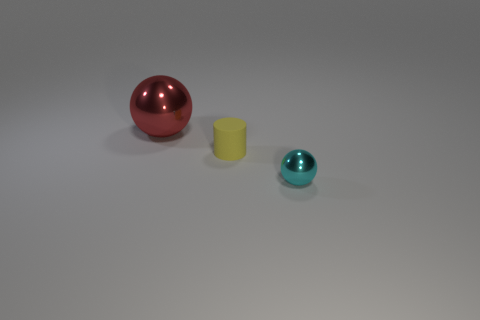What is the size of the thing that is both on the left side of the tiny cyan ball and right of the red thing? Based on the image, the item located to the left of the tiny cyan ball and to the right of the red object is a small yellow cylinder. It appears to be larger than the tiny cyan ball but smaller than the red object. 